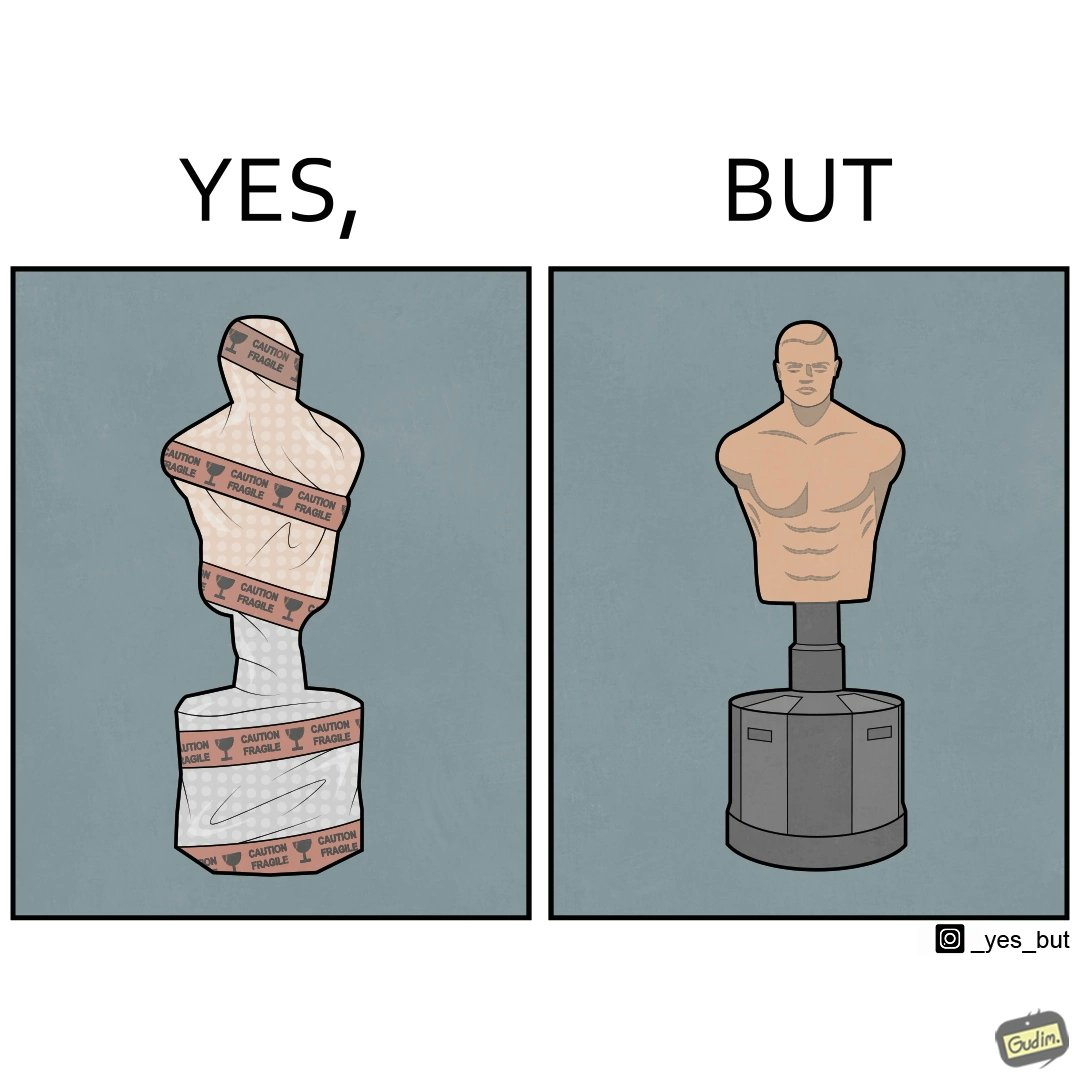Describe the contrast between the left and right parts of this image. In the left part of the image: The image shows an object wrapped in a "caution fragile" tape indicating that the object under the wraps is fragile. In the right part of the image: The image shows punching body bob with a base. It is used to practice punches and kicks. 